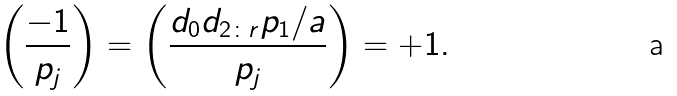Convert formula to latex. <formula><loc_0><loc_0><loc_500><loc_500>\left ( \frac { - 1 } { p _ { j } } \right ) = \left ( \frac { d _ { 0 } d _ { 2 \colon r } p _ { 1 } / a } { p _ { j } } \right ) = + 1 .</formula> 